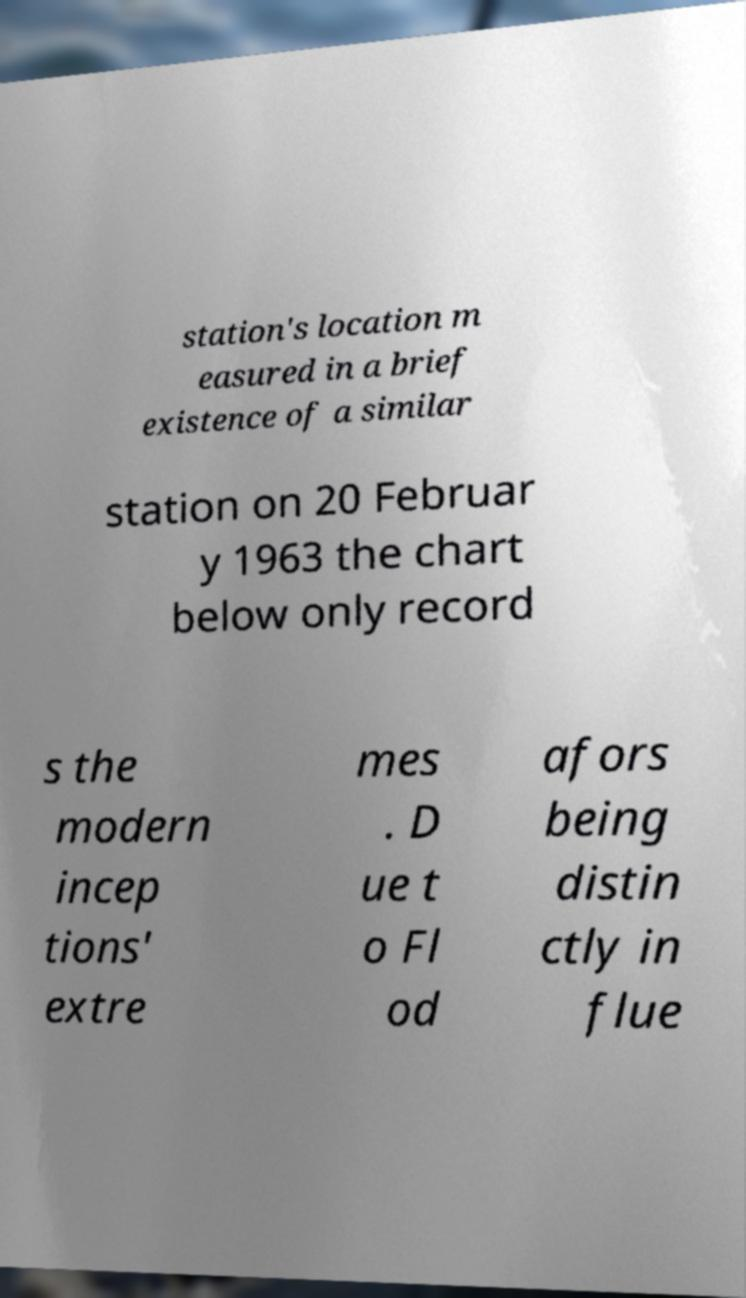Can you read and provide the text displayed in the image?This photo seems to have some interesting text. Can you extract and type it out for me? station's location m easured in a brief existence of a similar station on 20 Februar y 1963 the chart below only record s the modern incep tions' extre mes . D ue t o Fl od afors being distin ctly in flue 